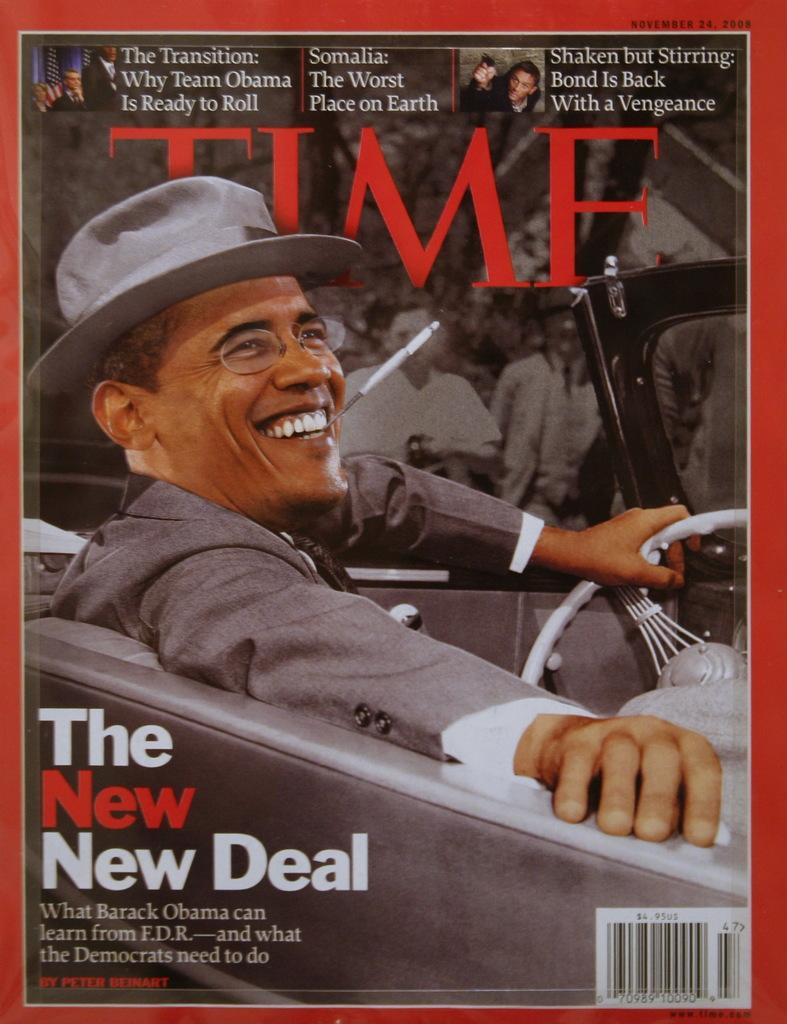<image>
Present a compact description of the photo's key features. Time magazine cover featuring the President and the words The New Deal. 